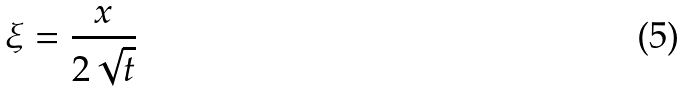Convert formula to latex. <formula><loc_0><loc_0><loc_500><loc_500>\xi = \frac { x } { 2 \sqrt { t } }</formula> 